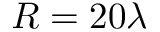<formula> <loc_0><loc_0><loc_500><loc_500>R = 2 0 \lambda</formula> 